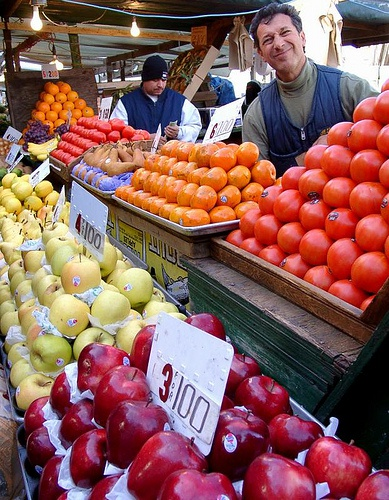Describe the objects in this image and their specific colors. I can see people in black, gray, navy, and darkgray tones, apple in black, maroon, brown, and purple tones, orange in black, red, orange, and salmon tones, people in black, navy, lavender, and brown tones, and apple in black, brown, maroon, and violet tones in this image. 